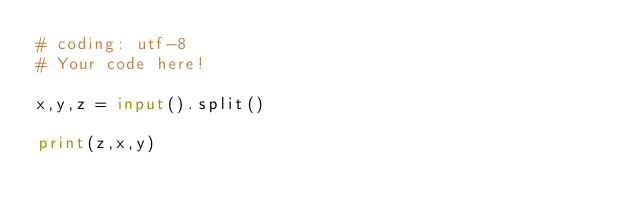Convert code to text. <code><loc_0><loc_0><loc_500><loc_500><_Python_># coding: utf-8
# Your code here!

x,y,z = input().split()

print(z,x,y)</code> 